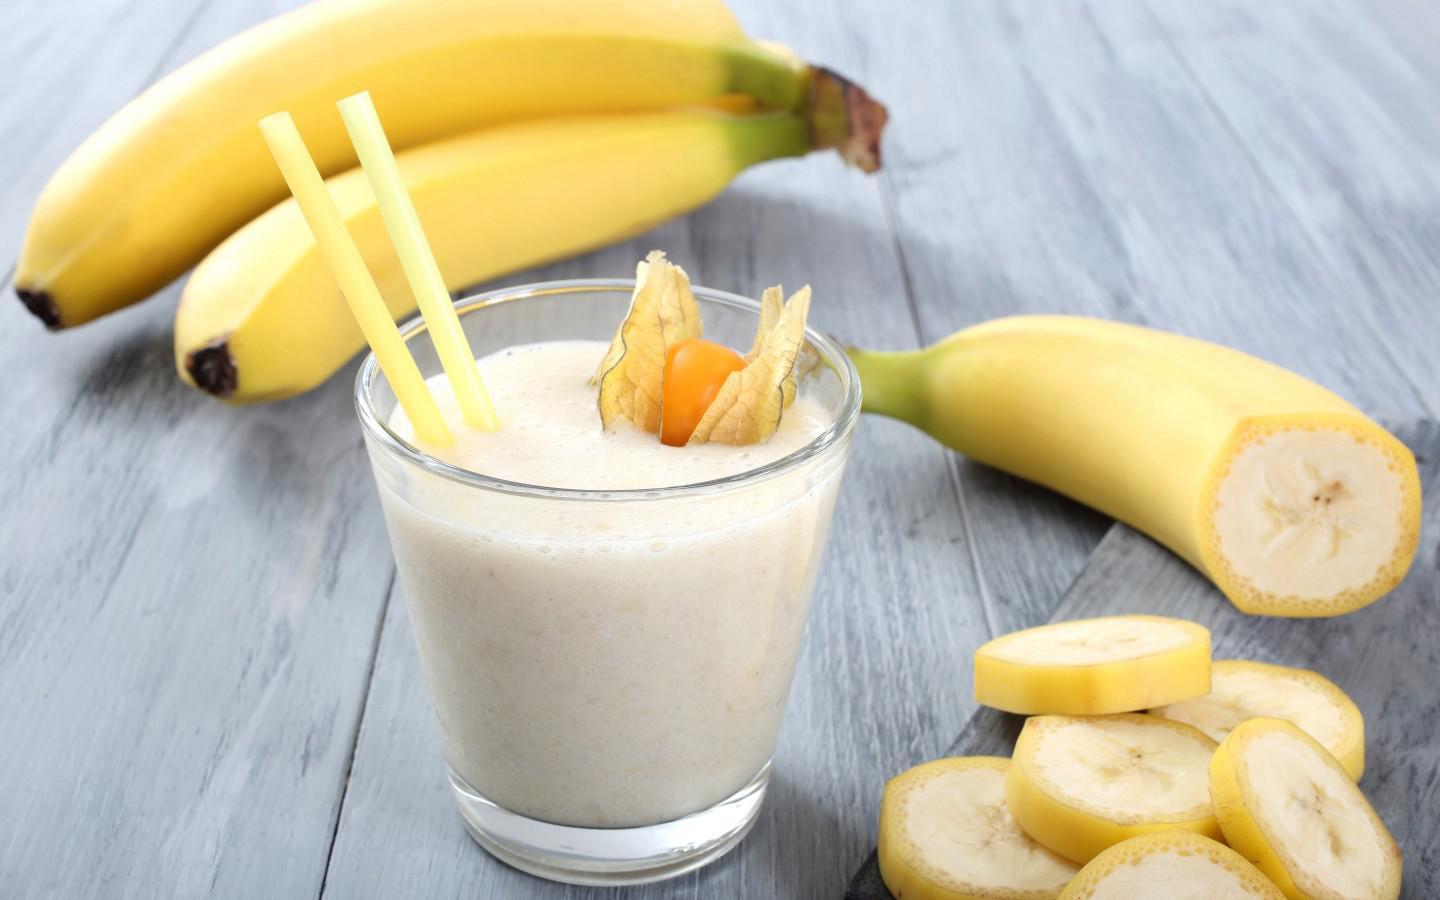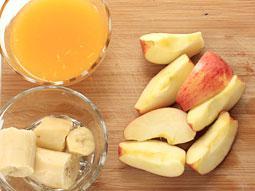The first image is the image on the left, the second image is the image on the right. Evaluate the accuracy of this statement regarding the images: "In one image, a creamy drink is served with a garnish in a clear glass that is sitting near at least two unpeeled pieces of fruit.". Is it true? Answer yes or no. Yes. The first image is the image on the left, the second image is the image on the right. Evaluate the accuracy of this statement regarding the images: "A glass containing a straw in a creamy beverage is in front of unpeeled bananas.". Is it true? Answer yes or no. Yes. 